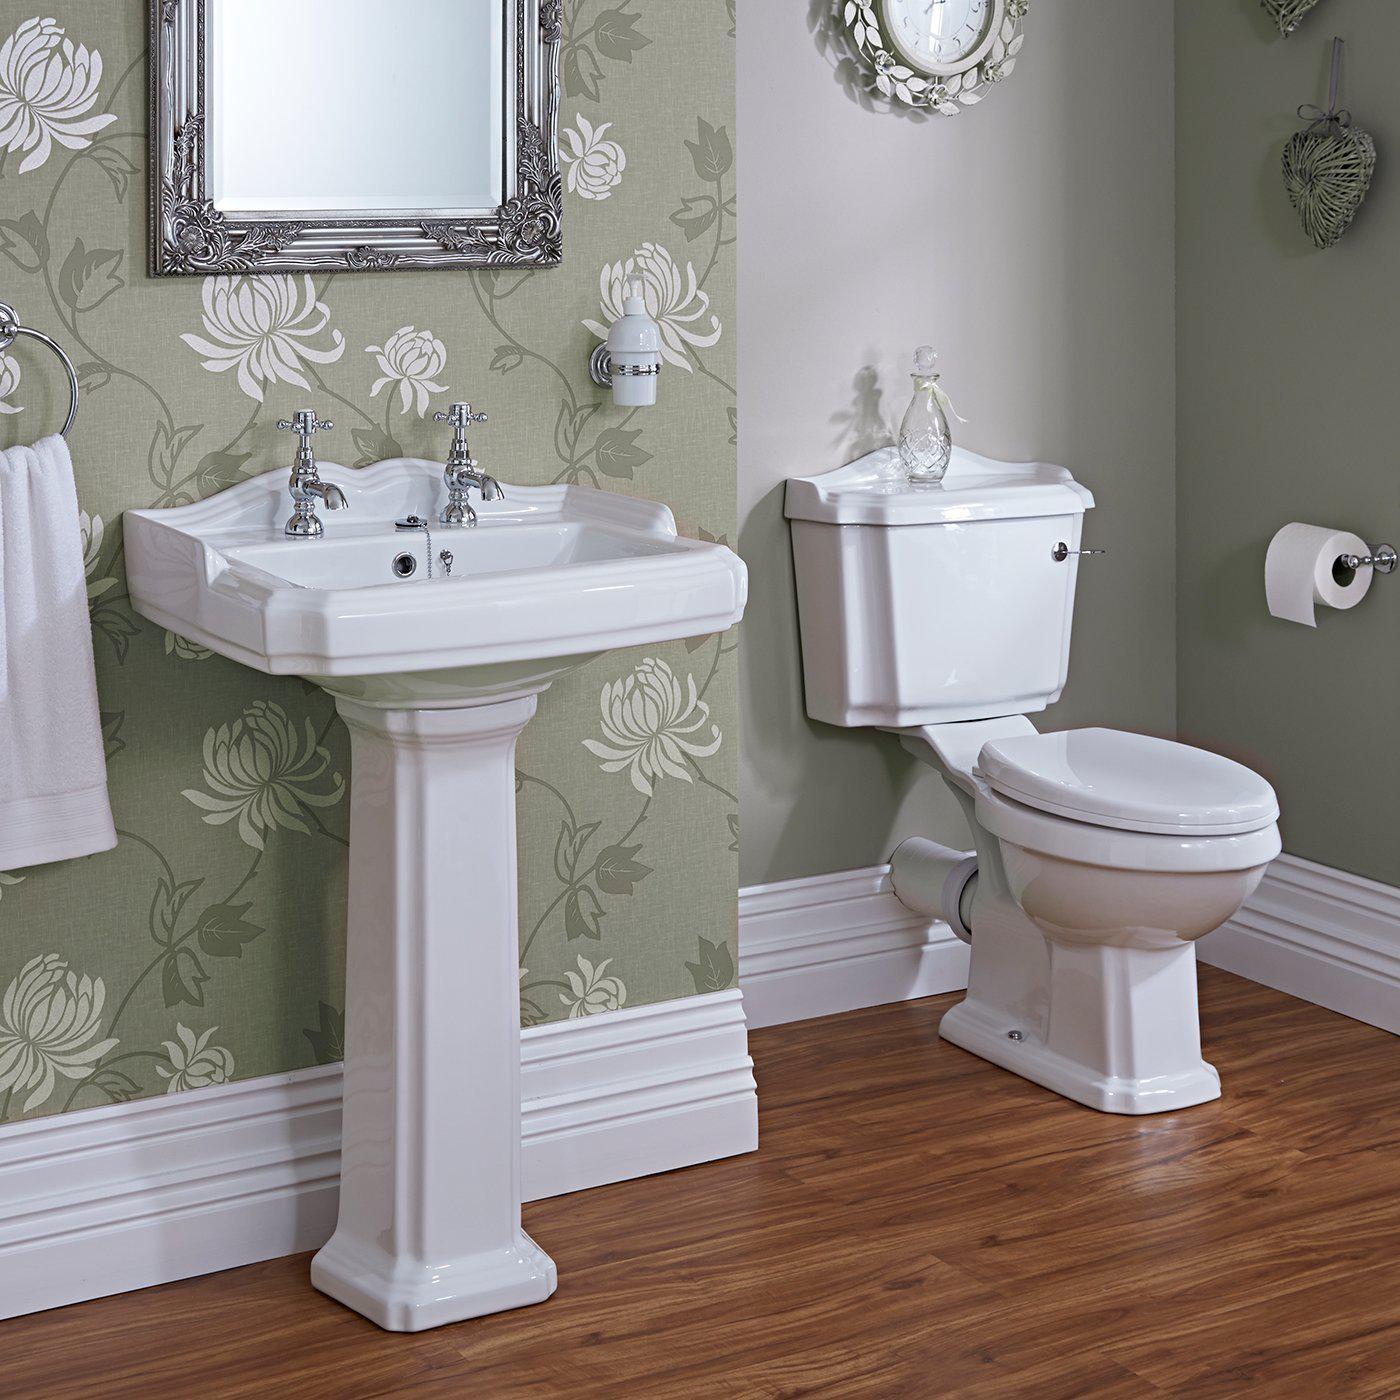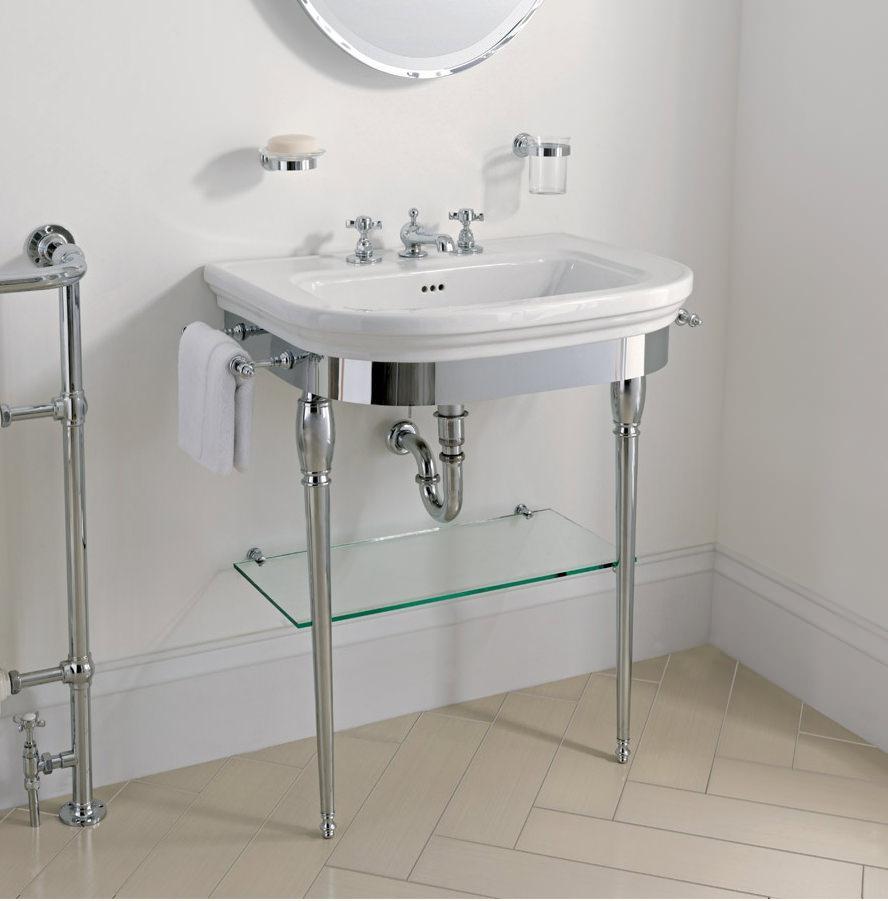The first image is the image on the left, the second image is the image on the right. Assess this claim about the two images: "There is a sink on a pillar in a room, with a mirror above it.". Correct or not? Answer yes or no. Yes. The first image is the image on the left, the second image is the image on the right. Analyze the images presented: Is the assertion "A toilet is sitting in a room with a white baseboard in one of the images." valid? Answer yes or no. Yes. 